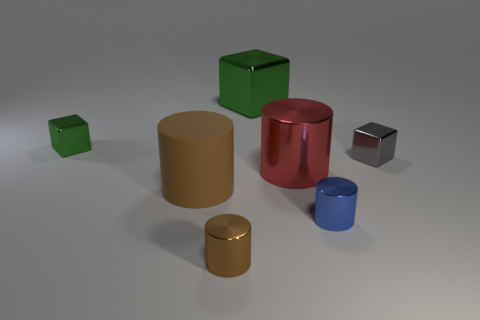Subtract all large brown rubber cylinders. How many cylinders are left? 3 Add 1 big matte things. How many objects exist? 8 Subtract all blue cylinders. How many cylinders are left? 3 Subtract 2 cylinders. How many cylinders are left? 2 Subtract all gray blocks. Subtract all blue balls. How many blocks are left? 2 Subtract all blue spheres. How many brown cylinders are left? 2 Subtract all balls. Subtract all gray shiny things. How many objects are left? 6 Add 3 tiny blue metal things. How many tiny blue metal things are left? 4 Add 4 red objects. How many red objects exist? 5 Subtract 0 cyan blocks. How many objects are left? 7 